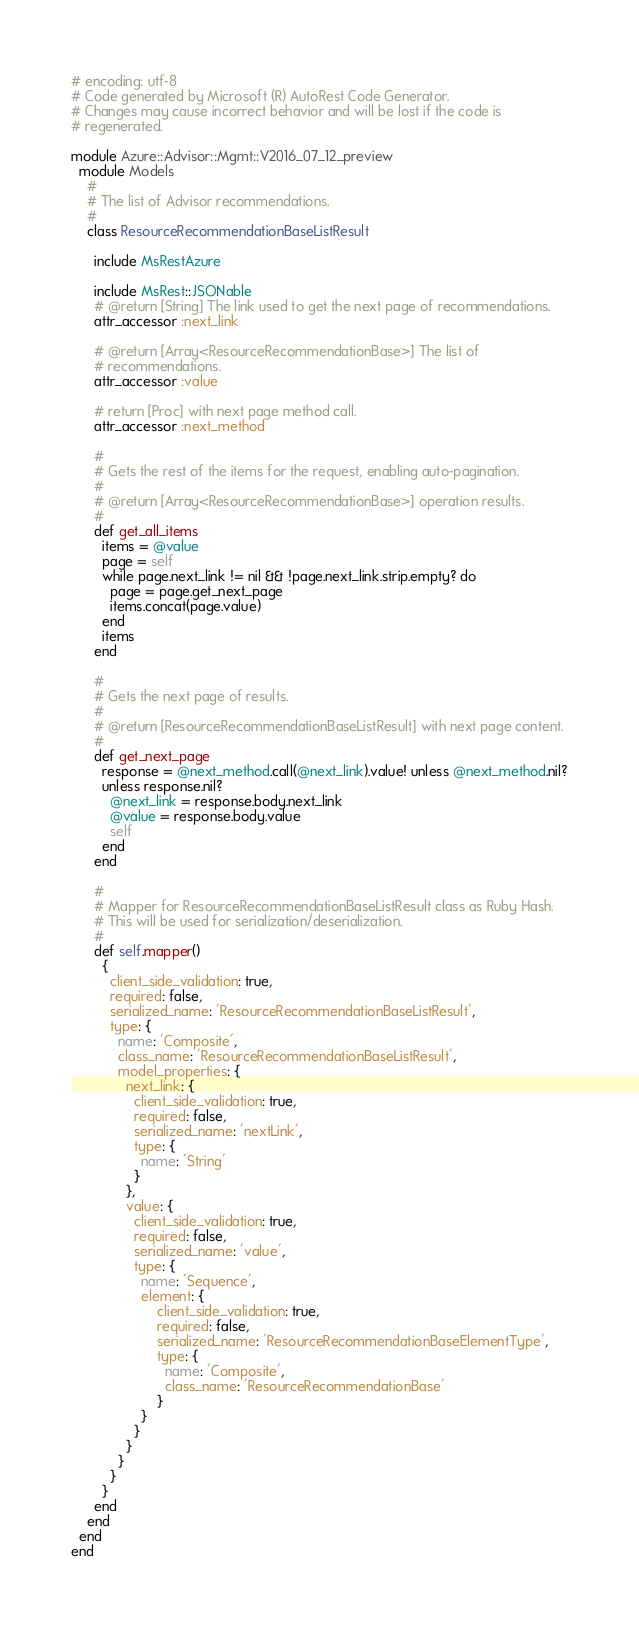Convert code to text. <code><loc_0><loc_0><loc_500><loc_500><_Ruby_># encoding: utf-8
# Code generated by Microsoft (R) AutoRest Code Generator.
# Changes may cause incorrect behavior and will be lost if the code is
# regenerated.

module Azure::Advisor::Mgmt::V2016_07_12_preview
  module Models
    #
    # The list of Advisor recommendations.
    #
    class ResourceRecommendationBaseListResult

      include MsRestAzure

      include MsRest::JSONable
      # @return [String] The link used to get the next page of recommendations.
      attr_accessor :next_link

      # @return [Array<ResourceRecommendationBase>] The list of
      # recommendations.
      attr_accessor :value

      # return [Proc] with next page method call.
      attr_accessor :next_method

      #
      # Gets the rest of the items for the request, enabling auto-pagination.
      #
      # @return [Array<ResourceRecommendationBase>] operation results.
      #
      def get_all_items
        items = @value
        page = self
        while page.next_link != nil && !page.next_link.strip.empty? do
          page = page.get_next_page
          items.concat(page.value)
        end
        items
      end

      #
      # Gets the next page of results.
      #
      # @return [ResourceRecommendationBaseListResult] with next page content.
      #
      def get_next_page
        response = @next_method.call(@next_link).value! unless @next_method.nil?
        unless response.nil?
          @next_link = response.body.next_link
          @value = response.body.value
          self
        end
      end

      #
      # Mapper for ResourceRecommendationBaseListResult class as Ruby Hash.
      # This will be used for serialization/deserialization.
      #
      def self.mapper()
        {
          client_side_validation: true,
          required: false,
          serialized_name: 'ResourceRecommendationBaseListResult',
          type: {
            name: 'Composite',
            class_name: 'ResourceRecommendationBaseListResult',
            model_properties: {
              next_link: {
                client_side_validation: true,
                required: false,
                serialized_name: 'nextLink',
                type: {
                  name: 'String'
                }
              },
              value: {
                client_side_validation: true,
                required: false,
                serialized_name: 'value',
                type: {
                  name: 'Sequence',
                  element: {
                      client_side_validation: true,
                      required: false,
                      serialized_name: 'ResourceRecommendationBaseElementType',
                      type: {
                        name: 'Composite',
                        class_name: 'ResourceRecommendationBase'
                      }
                  }
                }
              }
            }
          }
        }
      end
    end
  end
end
</code> 